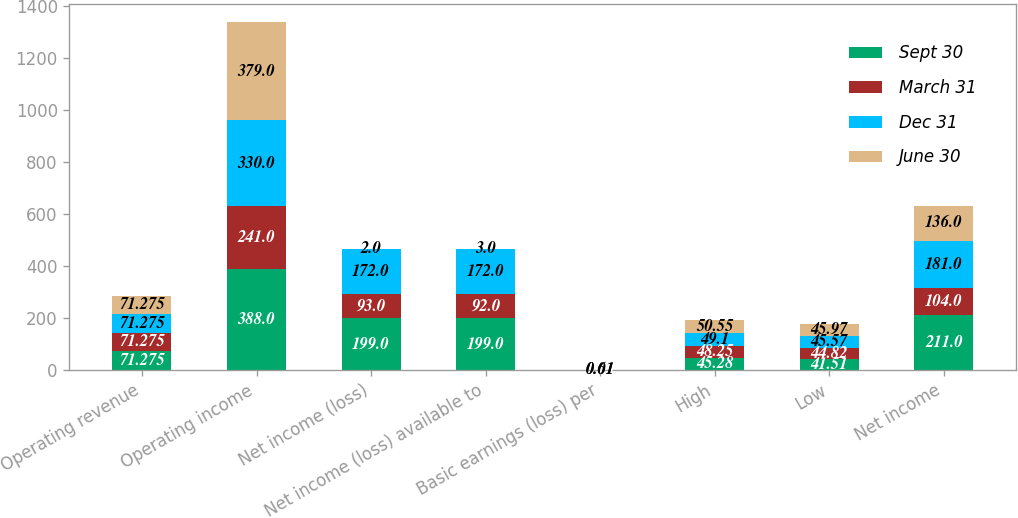Convert chart to OTSL. <chart><loc_0><loc_0><loc_500><loc_500><stacked_bar_chart><ecel><fcel>Operating revenue<fcel>Operating income<fcel>Net income (loss)<fcel>Net income (loss) available to<fcel>Basic earnings (loss) per<fcel>High<fcel>Low<fcel>Net income<nl><fcel>Sept 30<fcel>71.275<fcel>388<fcel>199<fcel>199<fcel>0.71<fcel>45.28<fcel>41.51<fcel>211<nl><fcel>March 31<fcel>71.275<fcel>241<fcel>93<fcel>92<fcel>0.33<fcel>48.25<fcel>44.82<fcel>104<nl><fcel>Dec 31<fcel>71.275<fcel>330<fcel>172<fcel>172<fcel>0.61<fcel>49.1<fcel>45.57<fcel>181<nl><fcel>June 30<fcel>71.275<fcel>379<fcel>2<fcel>3<fcel>0.01<fcel>50.55<fcel>45.97<fcel>136<nl></chart> 